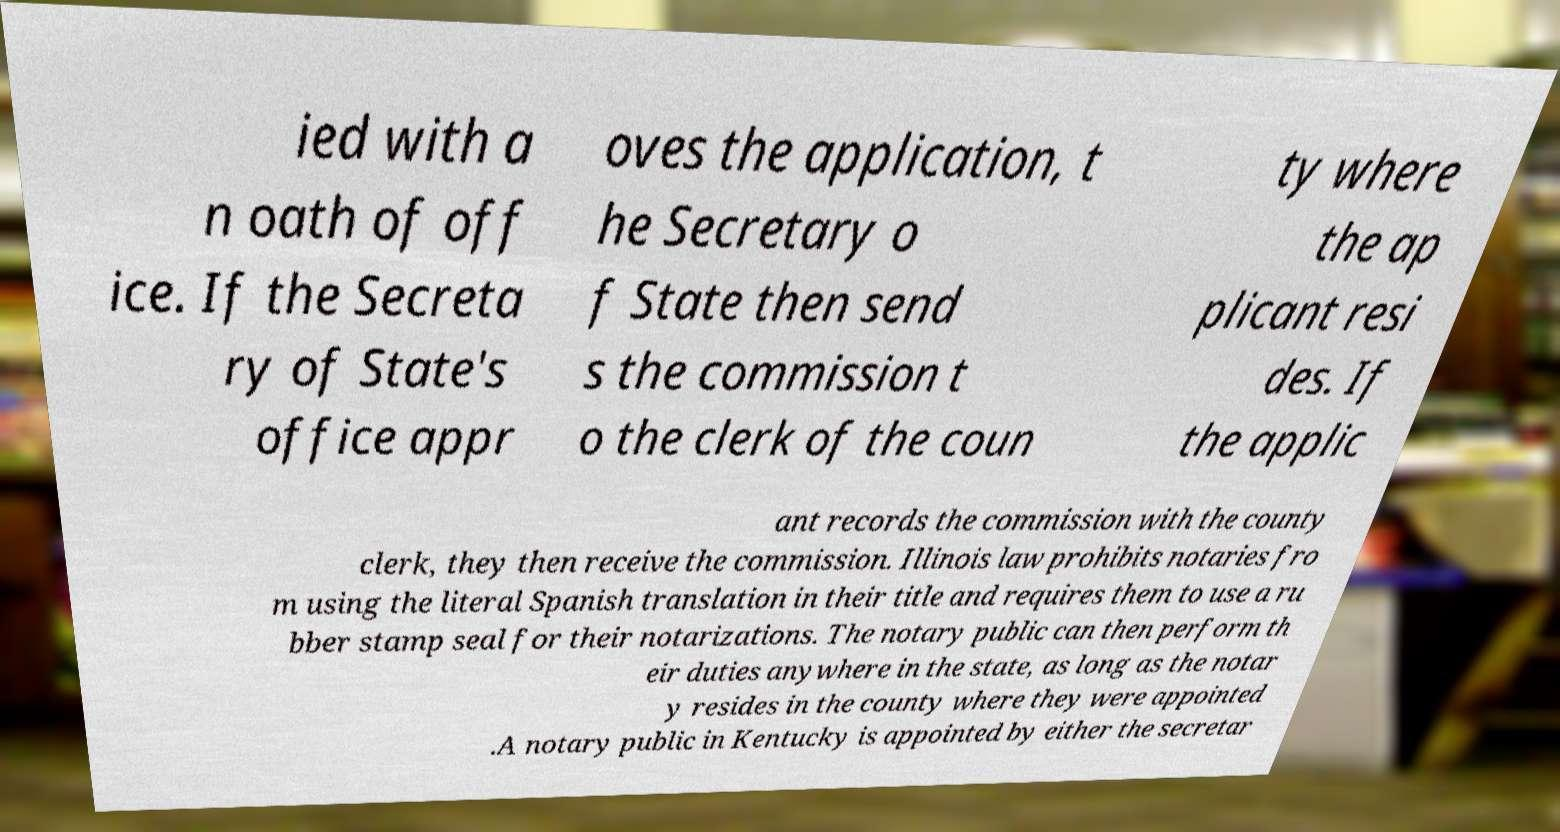What messages or text are displayed in this image? I need them in a readable, typed format. ied with a n oath of off ice. If the Secreta ry of State's office appr oves the application, t he Secretary o f State then send s the commission t o the clerk of the coun ty where the ap plicant resi des. If the applic ant records the commission with the county clerk, they then receive the commission. Illinois law prohibits notaries fro m using the literal Spanish translation in their title and requires them to use a ru bber stamp seal for their notarizations. The notary public can then perform th eir duties anywhere in the state, as long as the notar y resides in the county where they were appointed .A notary public in Kentucky is appointed by either the secretar 